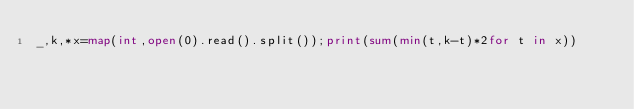<code> <loc_0><loc_0><loc_500><loc_500><_Python_>_,k,*x=map(int,open(0).read().split());print(sum(min(t,k-t)*2for t in x))</code> 